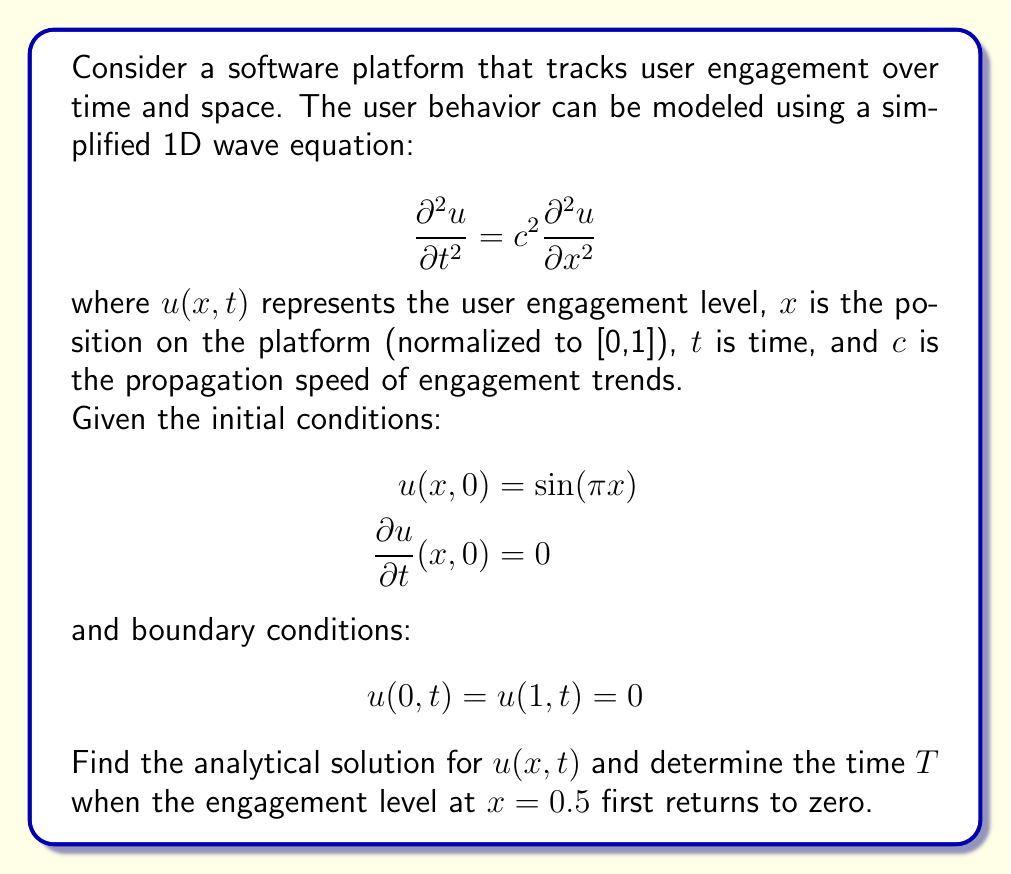Could you help me with this problem? To solve this problem, we'll follow these steps:

1) The general solution for the 1D wave equation with the given boundary conditions is:

   $$u(x,t) = \sum_{n=1}^{\infty} (A_n \cos(n\pi ct) + B_n \sin(n\pi ct)) \sin(n\pi x)$$

2) Given the initial conditions, we can determine that $B_n = 0$ for all $n$, and $A_n = 0$ for all $n \neq 1$. For $n=1$, we have:

   $$u(x,0) = A_1 \sin(\pi x) = \sin(\pi x)$$

   Therefore, $A_1 = 1$.

3) The solution thus simplifies to:

   $$u(x,t) = \cos(\pi ct) \sin(\pi x)$$

4) To find when the engagement level at $x=0.5$ first returns to zero, we solve:

   $$u(0.5,T) = \cos(\pi cT) \sin(\pi(0.5)) = 0$$

   We know that $\sin(\pi(0.5)) = 1$, so we need:

   $$\cos(\pi cT) = 0$$

5) The smallest positive value of $T$ that satisfies this is:

   $$\pi cT = \frac{\pi}{2}$$
   $$T = \frac{1}{2c}$$

This result shows that the time for the engagement level to return to zero at the center of the platform depends inversely on the propagation speed of engagement trends.
Answer: The analytical solution is:
$$u(x,t) = \cos(\pi ct) \sin(\pi x)$$

The time $T$ when the engagement level at $x=0.5$ first returns to zero is:
$$T = \frac{1}{2c}$$ 